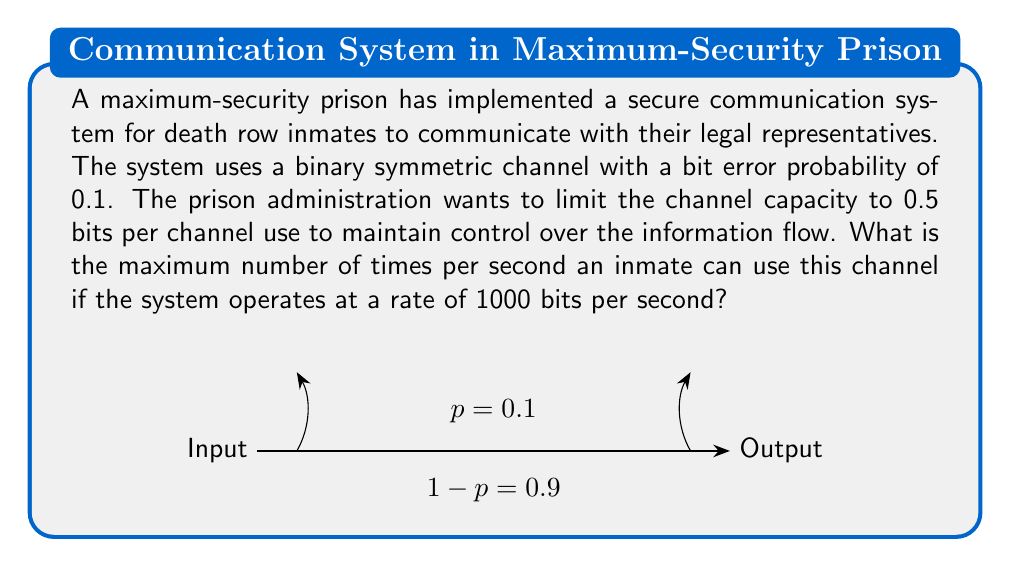Can you solve this math problem? To solve this problem, we need to follow these steps:

1) First, let's recall the formula for the capacity of a binary symmetric channel:

   $$C = 1 - H(p)$$

   where $H(p)$ is the binary entropy function:

   $$H(p) = -p \log_2(p) - (1-p) \log_2(1-p)$$

2) Given $p = 0.1$, let's calculate $H(p)$:

   $$H(0.1) = -0.1 \log_2(0.1) - 0.9 \log_2(0.9)$$
   $$\approx 0.469$$

3) Now we can calculate the channel capacity:

   $$C = 1 - H(0.1) \approx 1 - 0.469 = 0.531$$ bits per channel use

4) However, the prison administration wants to limit the capacity to 0.5 bits per channel use. This means each channel use will effectively transmit 0.5 bits of information.

5) The system operates at 1000 bits per second. To find how many times per second an inmate can use the channel, we divide the total bits per second by the bits per channel use:

   $$\text{Uses per second} = \frac{1000 \text{ bits/second}}{0.5 \text{ bits/use}} = 2000 \text{ uses/second}$$

Therefore, an inmate can use this channel 2000 times per second while maintaining the administration's desired information flow limit.
Answer: 2000 uses per second 